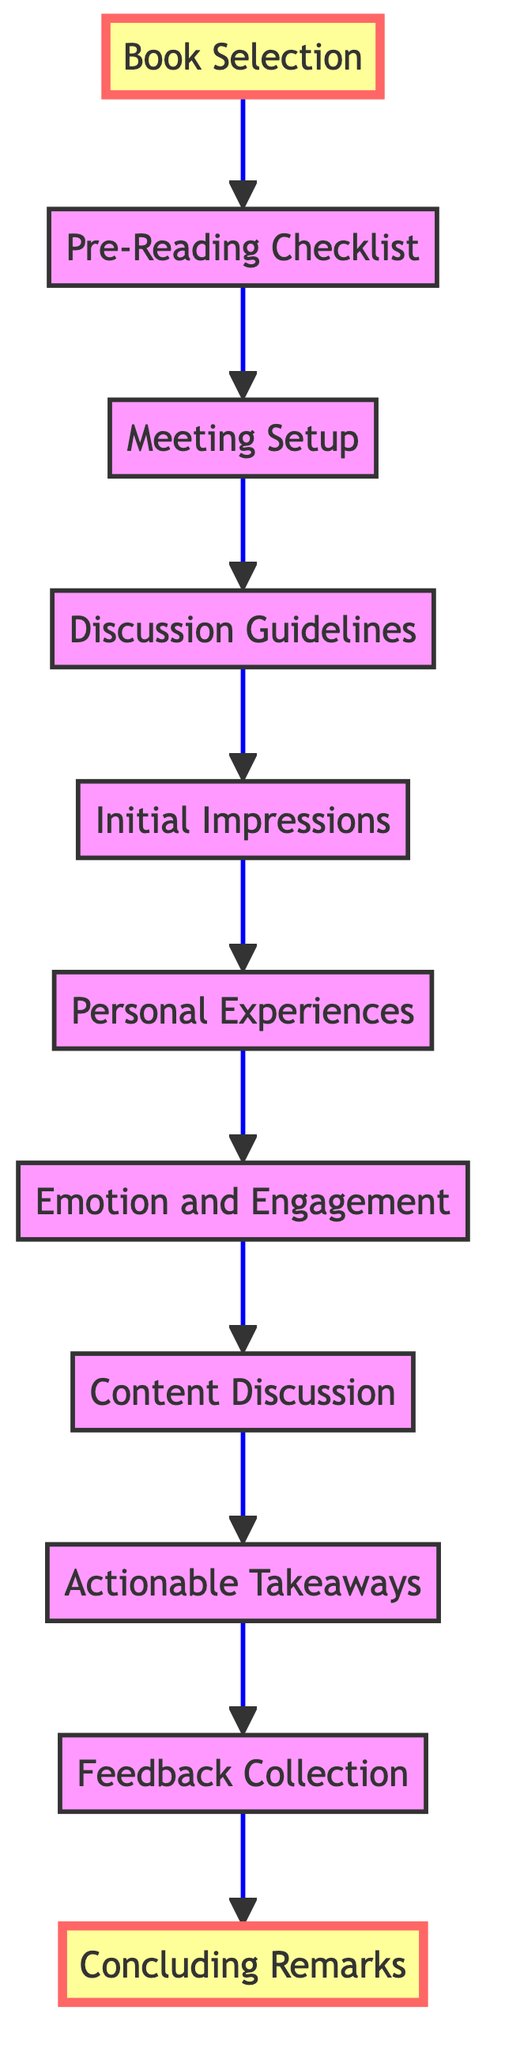What is the first step in the book club discussion process? The first step in the process is "Book Selection," which initiates the flow of the discussion and establishes the chosen medical thriller.
Answer: Book Selection How many main steps are there in the flow chart? By counting the nodes from "Book Selection" to "Concluding Remarks," there are a total of 11 main steps in the flow chart.
Answer: 11 What is the step immediately following "Discussion Guidelines"? The step immediately following "Discussion Guidelines" is "Initial Impressions," indicating the next topic of discussion after setting the guidelines.
Answer: Initial Impressions What are the final two steps in the process? The final two steps in the process are "Feedback Collection" and "Concluding Remarks," which wrap up the discussion with feedback and a summary of key points.
Answer: Feedback Collection and Concluding Remarks What does the "Actionable Takeaways" step focus on? The "Actionable Takeaways" step focuses on identifying insights or lessons learned from the discussion, such as new perspectives or factual information about medical ethics.
Answer: Identify actionable insights What is the purpose of the "Pre-Reading Checklist"? The purpose of the "Pre-Reading Checklist" is to provide members with key points or questions to consider while reading the book, ensuring they engage critically with the material.
Answer: Provide key points or questions Which step emphasizes the importance of listening to different viewpoints? The step that emphasizes the importance of listening to different viewpoints is "Discussion Guidelines," where respectful conversation is encouraged among members.
Answer: Discussion Guidelines What is the relationship between "Emotion and Engagement" and "Content Discussion"? "Emotion and Engagement" occurs before "Content Discussion," suggesting that members first discuss their feelings about the book before exploring the book's major themes and medical accuracy.
Answer: Emotion and Engagement precedes Content Discussion 